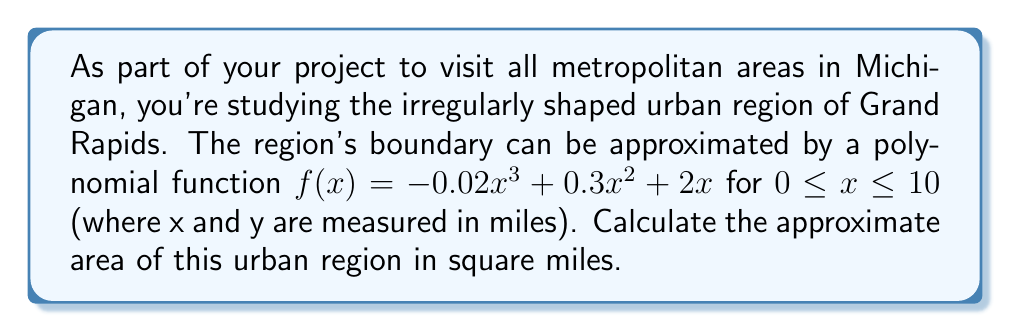Solve this math problem. To determine the area of this irregularly shaped urban region, we need to calculate the definite integral of the function $f(x)$ from $x=0$ to $x=10$. This process involves the following steps:

1) The function describing the region's boundary is:
   $f(x) = -0.02x^3 + 0.3x^2 + 2x$

2) To find the area, we integrate this function from 0 to 10:
   $$\text{Area} = \int_0^{10} (-0.02x^3 + 0.3x^2 + 2x) dx$$

3) Integrate each term:
   $$\int (-0.02x^3) dx = -0.005x^4$$
   $$\int (0.3x^2) dx = 0.1x^3$$
   $$\int (2x) dx = x^2$$

4) Apply the fundamental theorem of calculus:
   $$\text{Area} = [-0.005x^4 + 0.1x^3 + x^2]_0^{10}$$

5) Evaluate at the upper and lower bounds:
   At $x=10$: $-0.005(10^4) + 0.1(10^3) + 10^2 = -500 + 1000 + 100 = 600$
   At $x=0$: $-0.005(0^4) + 0.1(0^3) + 0^2 = 0$

6) Subtract the lower bound from the upper bound:
   $\text{Area} = 600 - 0 = 600$

Therefore, the approximate area of the Grand Rapids urban region is 600 square miles.
Answer: 600 square miles 